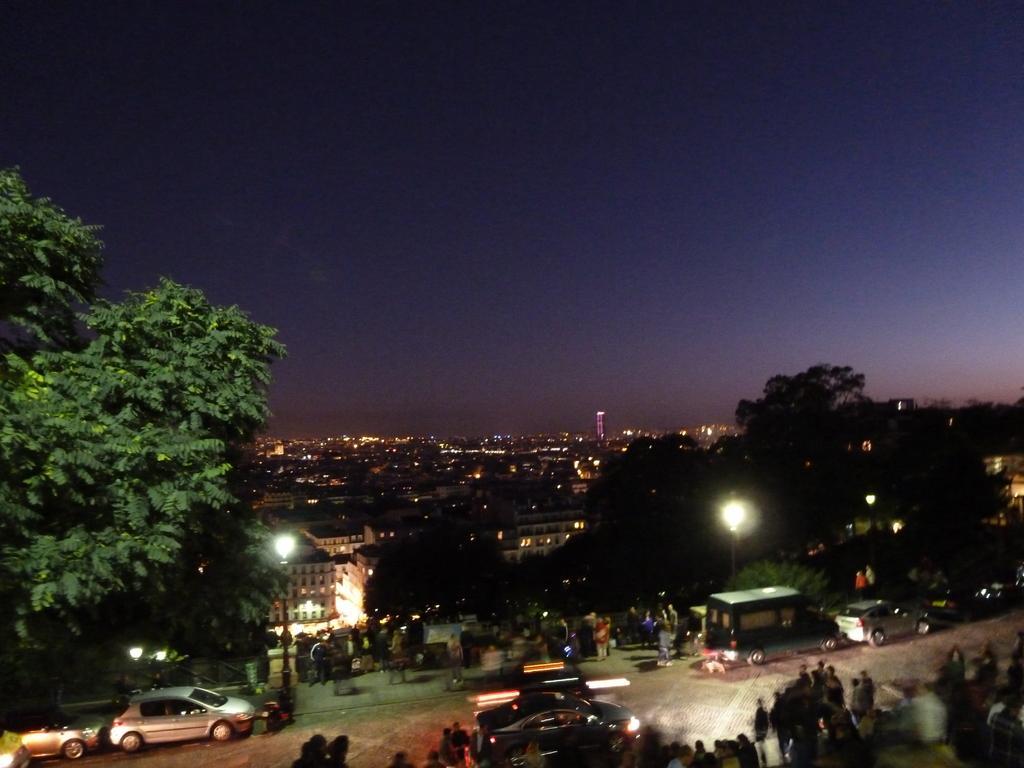In one or two sentences, can you explain what this image depicts? At the bottom of the picture, we see people standing on the road. Beside them, we see the cars which are moving on the road. Beside that, there are street lights. There are trees and buildings in the background. At the top, we see the sky. This picture might be clicked in the dark. 